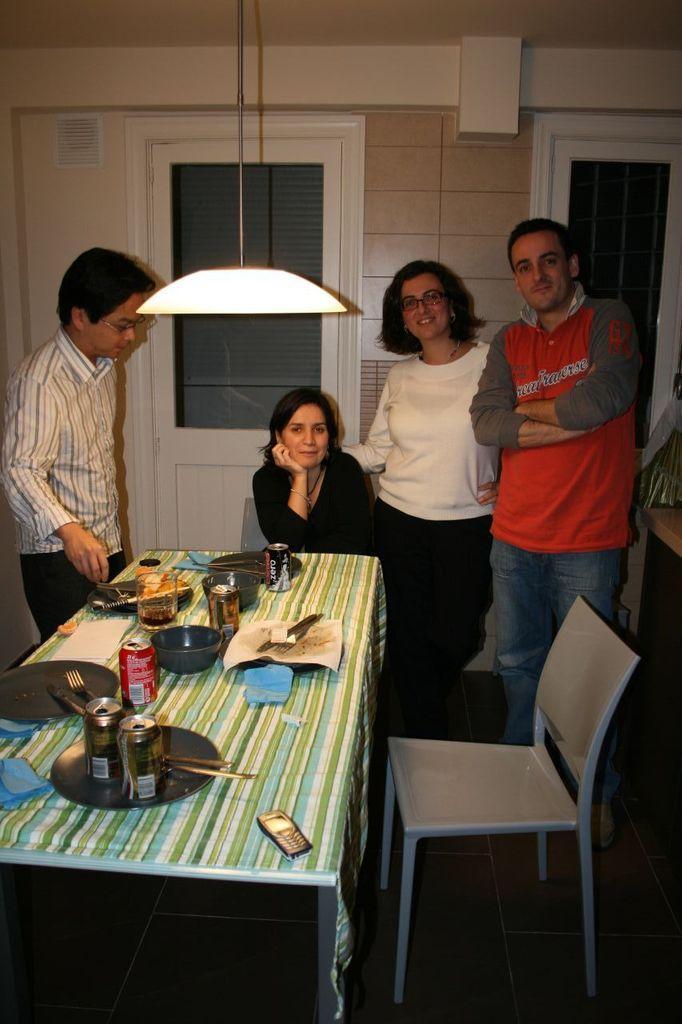In one or two sentences, can you explain what this image depicts? The picture is taken inside a room at the corner of the picture two persons are standing. One person is wearing a red t-shirt and jeans and another person is wearing white t-shirt and black pants, in front of him there is a chair and one table and on the table there are plates,cups,bowls,glasses and spoons and one mobile and left corner of the picture there is one person standing and in the middle there is one woman sitting on the chair and behind them there is a door and a wall and at the centre there is one lamp hanging from the roof. 